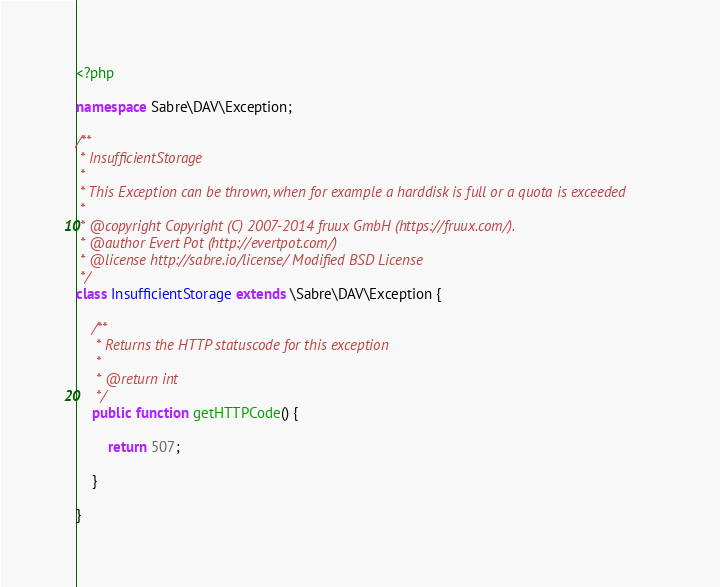<code> <loc_0><loc_0><loc_500><loc_500><_PHP_><?php

namespace Sabre\DAV\Exception;

/**
 * InsufficientStorage
 *
 * This Exception can be thrown, when for example a harddisk is full or a quota is exceeded
 *
 * @copyright Copyright (C) 2007-2014 fruux GmbH (https://fruux.com/).
 * @author Evert Pot (http://evertpot.com/)
 * @license http://sabre.io/license/ Modified BSD License
 */
class InsufficientStorage extends \Sabre\DAV\Exception {

    /**
     * Returns the HTTP statuscode for this exception
     *
     * @return int
     */
    public function getHTTPCode() {

        return 507;

    }

}
</code> 